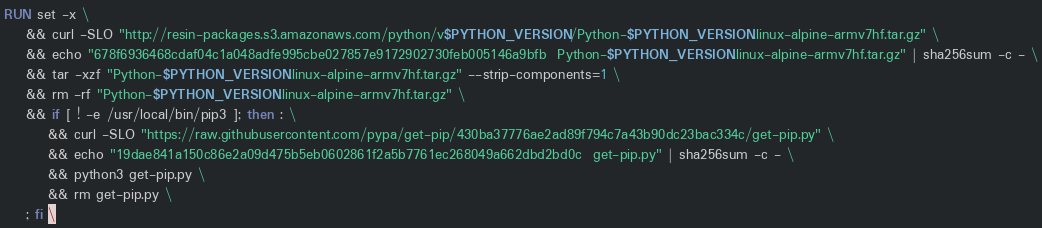Convert code to text. <code><loc_0><loc_0><loc_500><loc_500><_Dockerfile_>RUN set -x \
	&& curl -SLO "http://resin-packages.s3.amazonaws.com/python/v$PYTHON_VERSION/Python-$PYTHON_VERSION.linux-alpine-armv7hf.tar.gz" \
	&& echo "678f6936468cdaf04c1a048adfe995cbe027857e9172902730feb005146a9bfb  Python-$PYTHON_VERSION.linux-alpine-armv7hf.tar.gz" | sha256sum -c - \
	&& tar -xzf "Python-$PYTHON_VERSION.linux-alpine-armv7hf.tar.gz" --strip-components=1 \
	&& rm -rf "Python-$PYTHON_VERSION.linux-alpine-armv7hf.tar.gz" \
	&& if [ ! -e /usr/local/bin/pip3 ]; then : \
		&& curl -SLO "https://raw.githubusercontent.com/pypa/get-pip/430ba37776ae2ad89f794c7a43b90dc23bac334c/get-pip.py" \
		&& echo "19dae841a150c86e2a09d475b5eb0602861f2a5b7761ec268049a662dbd2bd0c  get-pip.py" | sha256sum -c - \
		&& python3 get-pip.py \
		&& rm get-pip.py \
	; fi \</code> 